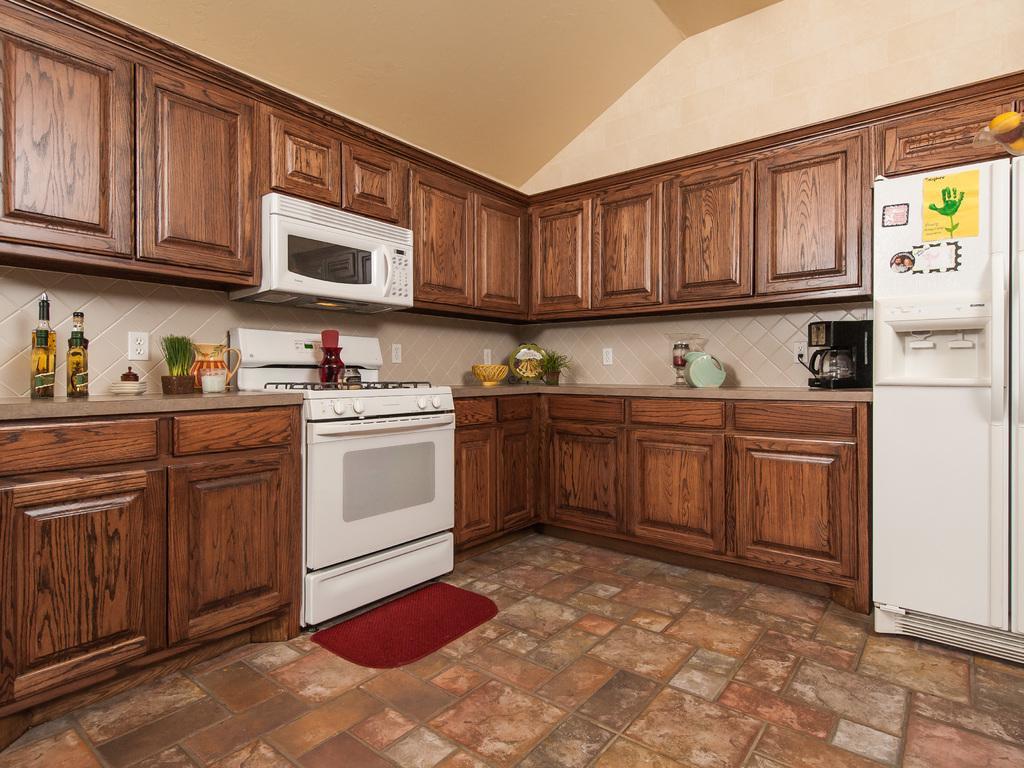In one or two sentences, can you explain what this image depicts? This picture is inside view of a kitchen. We can see cupboards, stove, bottles, container, plant, vessel, coffee machine, refrigerator, mat are present. At the top of the image roof is there. At the bottom of the image floor is present. 